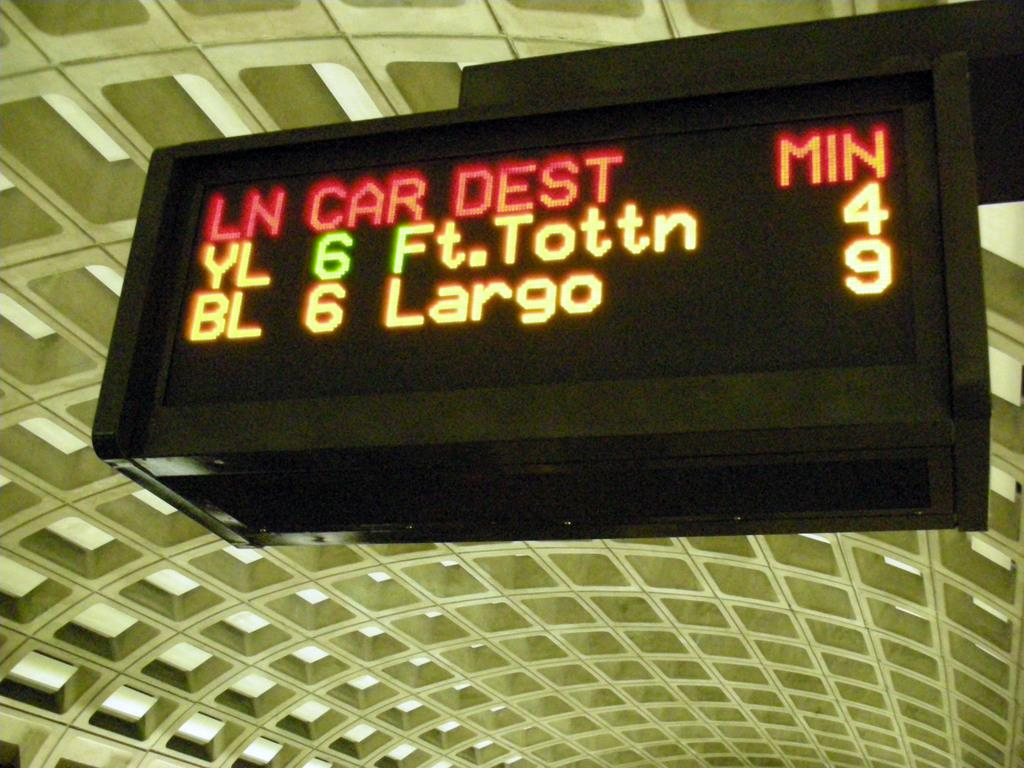<image>
Offer a succinct explanation of the picture presented. The train station shows the times of new trains coming into the station. 